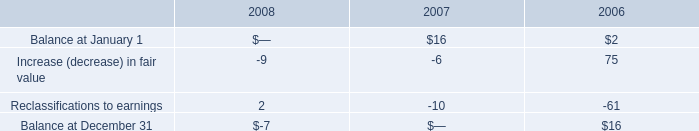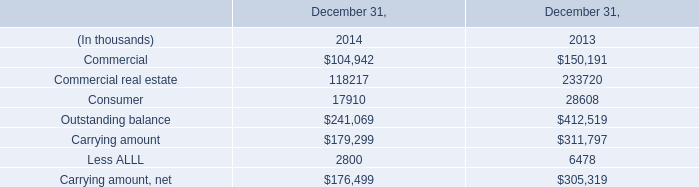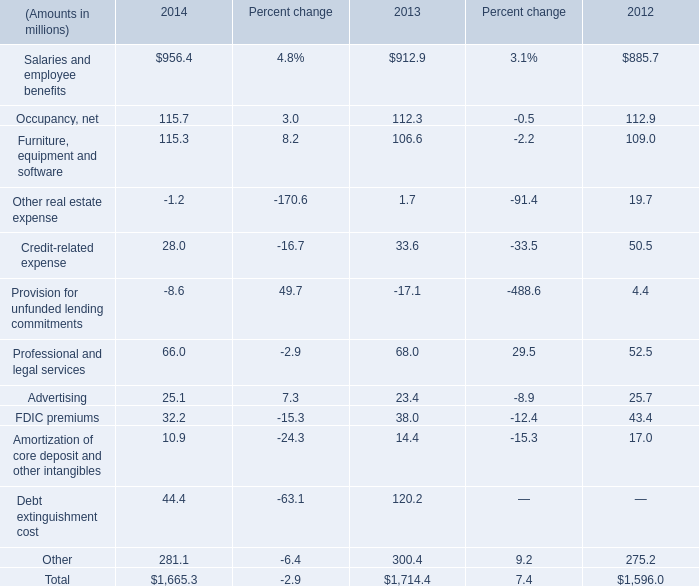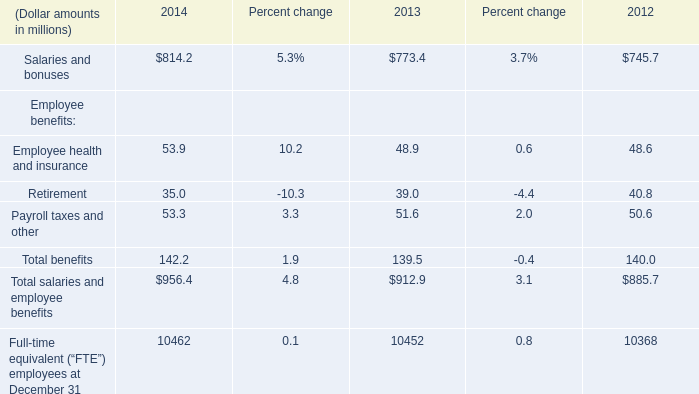What is the ratio of all 2014 that are smaller than 0 to the sum of 2014 in 2014? 
Computations: ((-1.2 - 8.6) / 1665.3)
Answer: -0.00588. 